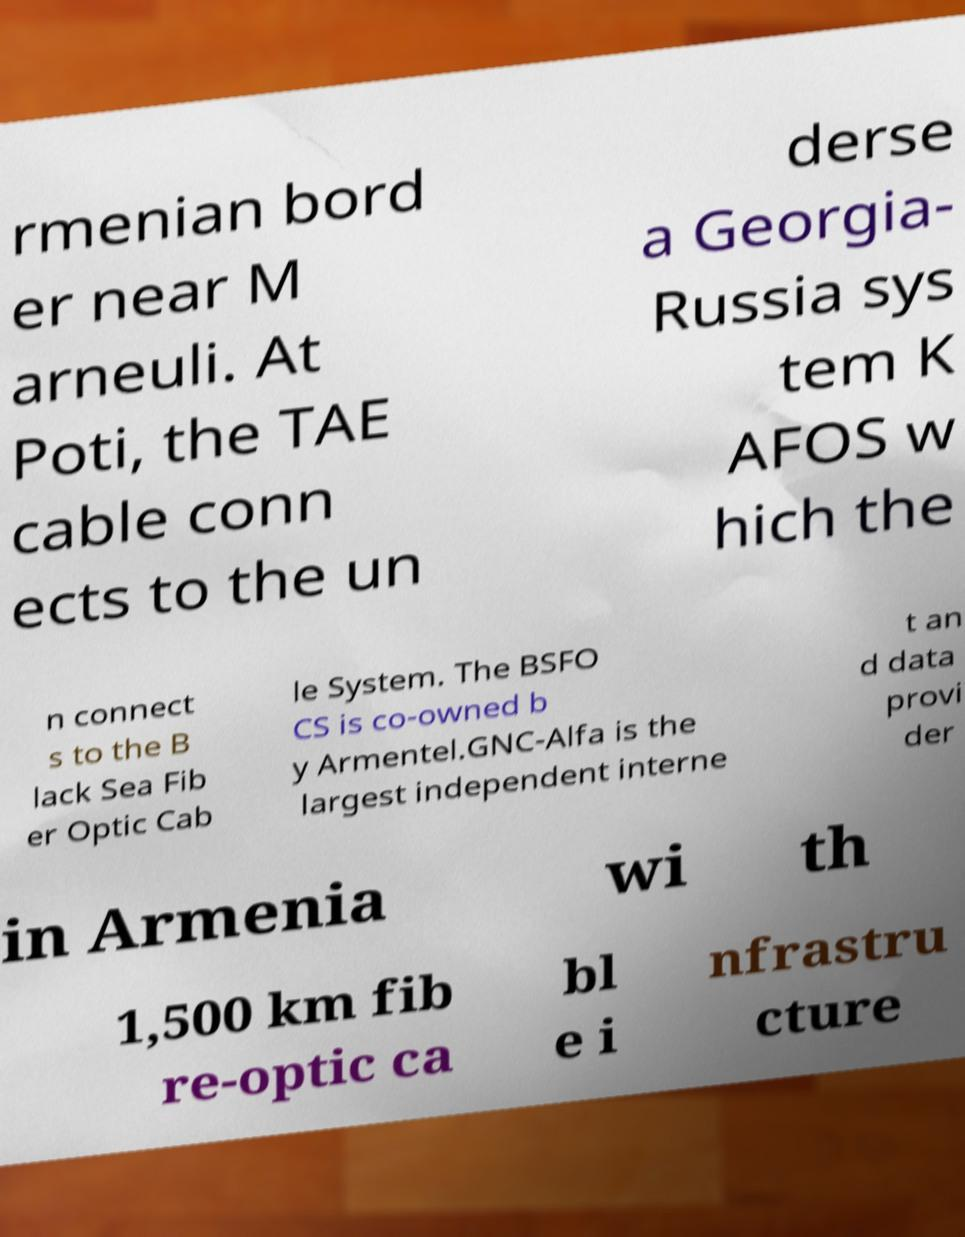What messages or text are displayed in this image? I need them in a readable, typed format. rmenian bord er near M arneuli. At Poti, the TAE cable conn ects to the un derse a Georgia- Russia sys tem K AFOS w hich the n connect s to the B lack Sea Fib er Optic Cab le System. The BSFO CS is co-owned b y Armentel.GNC-Alfa is the largest independent interne t an d data provi der in Armenia wi th 1,500 km fib re-optic ca bl e i nfrastru cture 